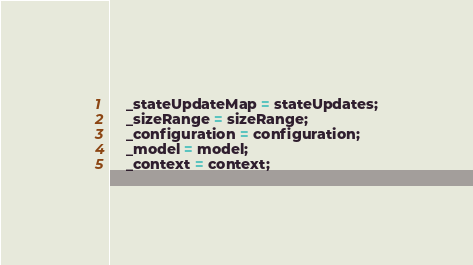Convert code to text. <code><loc_0><loc_0><loc_500><loc_500><_ObjectiveC_>    _stateUpdateMap = stateUpdates;
    _sizeRange = sizeRange;
    _configuration = configuration;
    _model = model;
    _context = context;</code> 